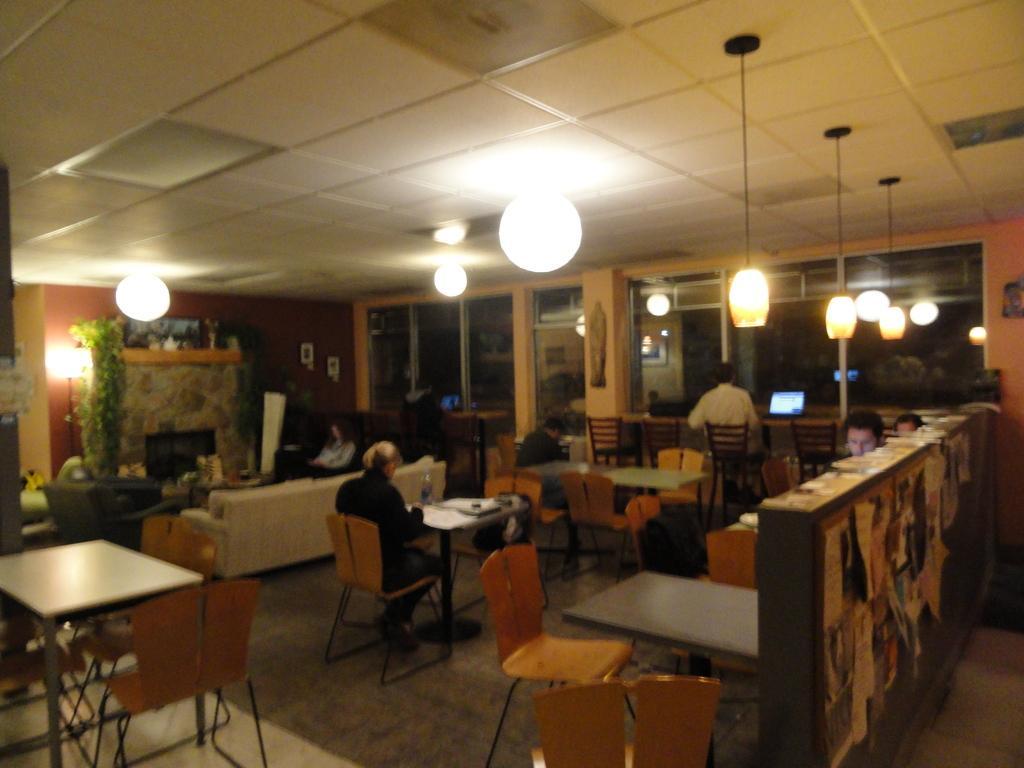Describe this image in one or two sentences. Here we can see a a table and some objects on it, and here a person is sitting, and here is the wall, and here are the lights, and here is the door. 